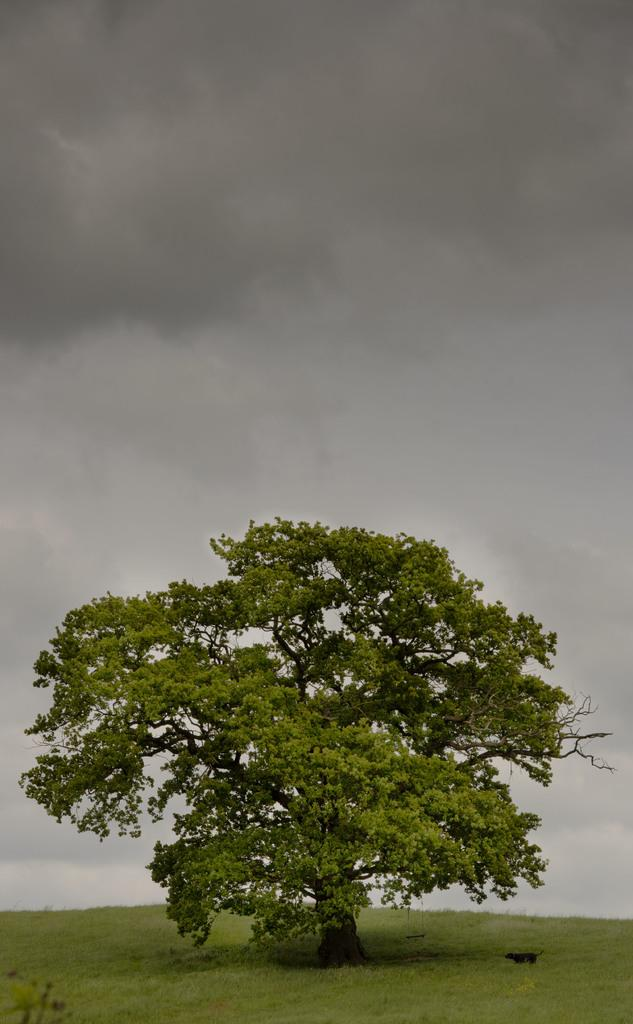What is the main subject of the image? The main subject of the image is a tree. Where is the tree located? The tree is in the middle of a grassland. What can be seen in the background of the image? The sky is visible in the image. What is the condition of the sky in the image? Clouds are present in the sky. What type of industry can be seen in the background of the image? There is no industry present in the image; it features a tree in a grassland with clouds in the sky. Is there a camp or station visible in the image? There is no camp or station present in the image; it features a tree in a grassland with clouds in the sky. 